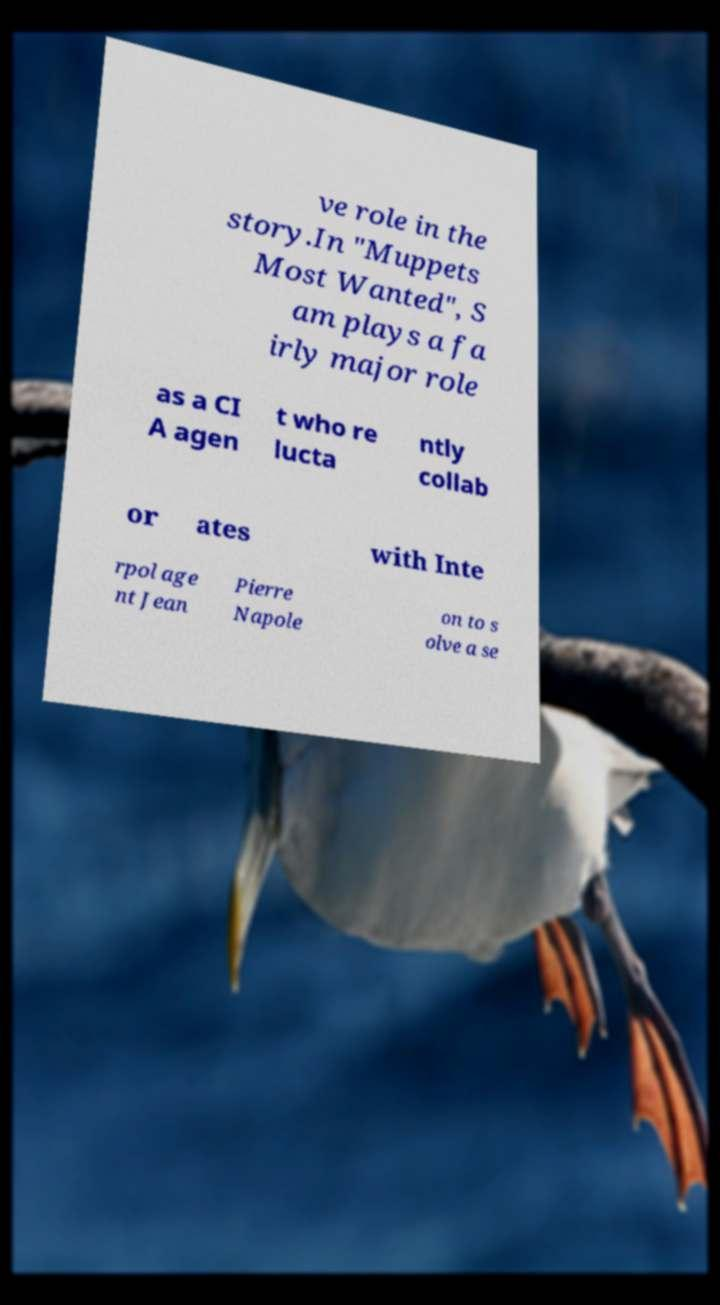Please read and relay the text visible in this image. What does it say? ve role in the story.In "Muppets Most Wanted", S am plays a fa irly major role as a CI A agen t who re lucta ntly collab or ates with Inte rpol age nt Jean Pierre Napole on to s olve a se 